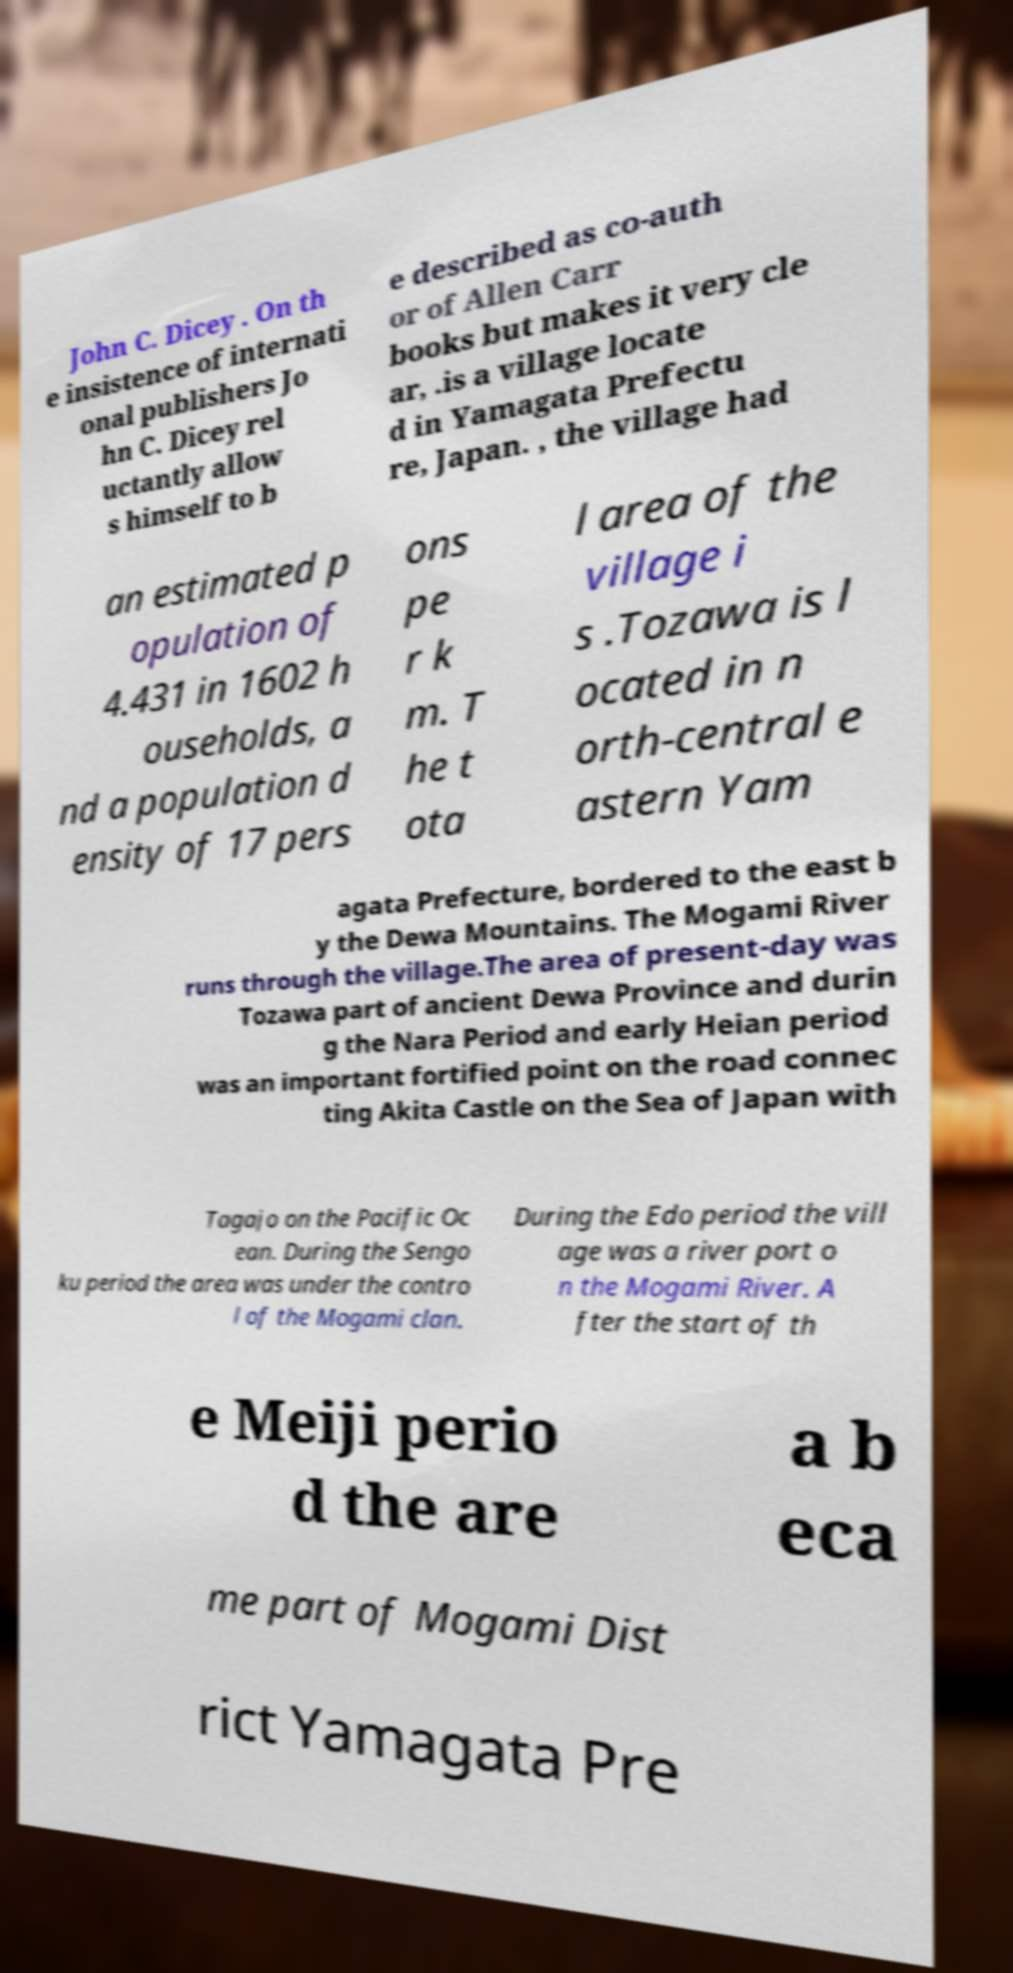Could you assist in decoding the text presented in this image and type it out clearly? John C. Dicey . On th e insistence of internati onal publishers Jo hn C. Dicey rel uctantly allow s himself to b e described as co-auth or of Allen Carr books but makes it very cle ar, .is a village locate d in Yamagata Prefectu re, Japan. , the village had an estimated p opulation of 4.431 in 1602 h ouseholds, a nd a population d ensity of 17 pers ons pe r k m. T he t ota l area of the village i s .Tozawa is l ocated in n orth-central e astern Yam agata Prefecture, bordered to the east b y the Dewa Mountains. The Mogami River runs through the village.The area of present-day was Tozawa part of ancient Dewa Province and durin g the Nara Period and early Heian period was an important fortified point on the road connec ting Akita Castle on the Sea of Japan with Tagajo on the Pacific Oc ean. During the Sengo ku period the area was under the contro l of the Mogami clan. During the Edo period the vill age was a river port o n the Mogami River. A fter the start of th e Meiji perio d the are a b eca me part of Mogami Dist rict Yamagata Pre 